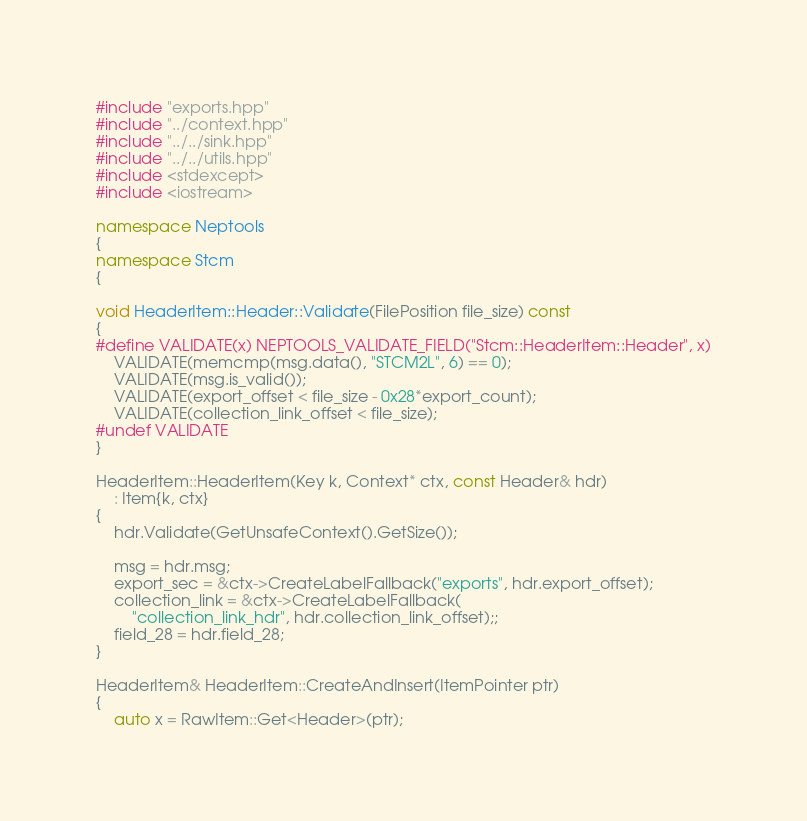Convert code to text. <code><loc_0><loc_0><loc_500><loc_500><_C++_>#include "exports.hpp"
#include "../context.hpp"
#include "../../sink.hpp"
#include "../../utils.hpp"
#include <stdexcept>
#include <iostream>

namespace Neptools
{
namespace Stcm
{

void HeaderItem::Header::Validate(FilePosition file_size) const
{
#define VALIDATE(x) NEPTOOLS_VALIDATE_FIELD("Stcm::HeaderItem::Header", x)
    VALIDATE(memcmp(msg.data(), "STCM2L", 6) == 0);
    VALIDATE(msg.is_valid());
    VALIDATE(export_offset < file_size - 0x28*export_count);
    VALIDATE(collection_link_offset < file_size);
#undef VALIDATE
}

HeaderItem::HeaderItem(Key k, Context* ctx, const Header& hdr)
    : Item{k, ctx}
{
    hdr.Validate(GetUnsafeContext().GetSize());

    msg = hdr.msg;
    export_sec = &ctx->CreateLabelFallback("exports", hdr.export_offset);
    collection_link = &ctx->CreateLabelFallback(
        "collection_link_hdr", hdr.collection_link_offset);;
    field_28 = hdr.field_28;
}

HeaderItem& HeaderItem::CreateAndInsert(ItemPointer ptr)
{
    auto x = RawItem::Get<Header>(ptr);
</code> 